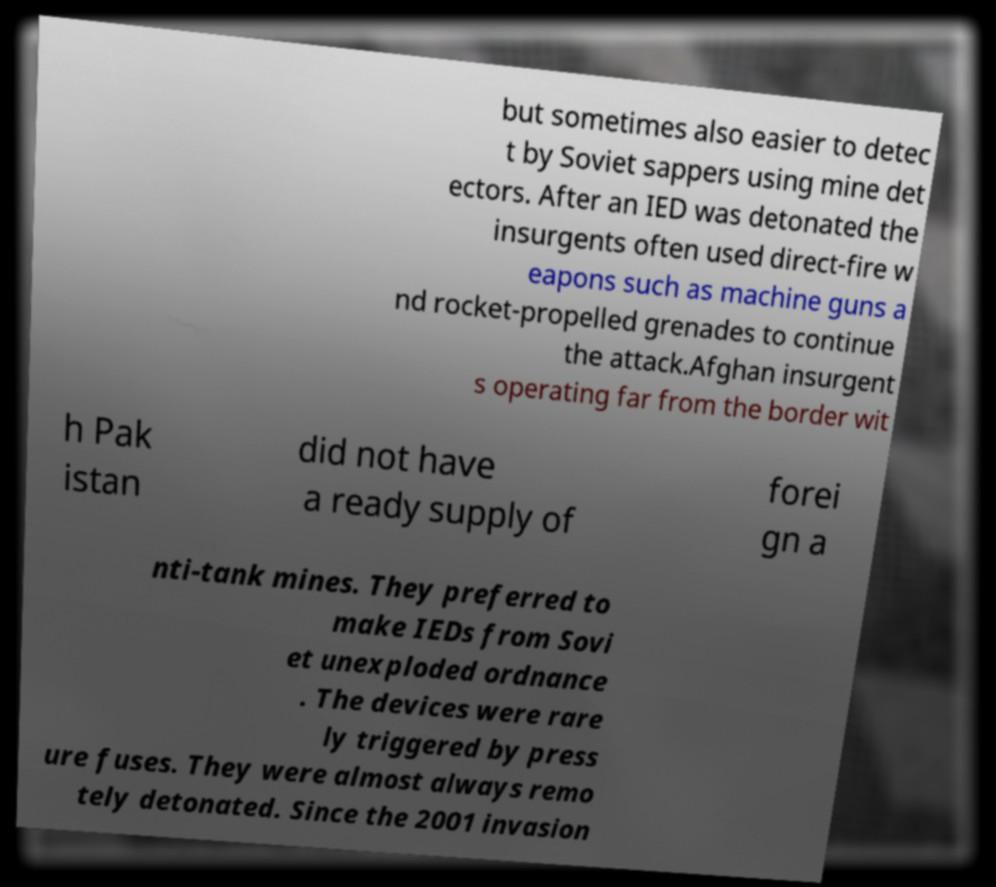Can you read and provide the text displayed in the image?This photo seems to have some interesting text. Can you extract and type it out for me? but sometimes also easier to detec t by Soviet sappers using mine det ectors. After an IED was detonated the insurgents often used direct-fire w eapons such as machine guns a nd rocket-propelled grenades to continue the attack.Afghan insurgent s operating far from the border wit h Pak istan did not have a ready supply of forei gn a nti-tank mines. They preferred to make IEDs from Sovi et unexploded ordnance . The devices were rare ly triggered by press ure fuses. They were almost always remo tely detonated. Since the 2001 invasion 